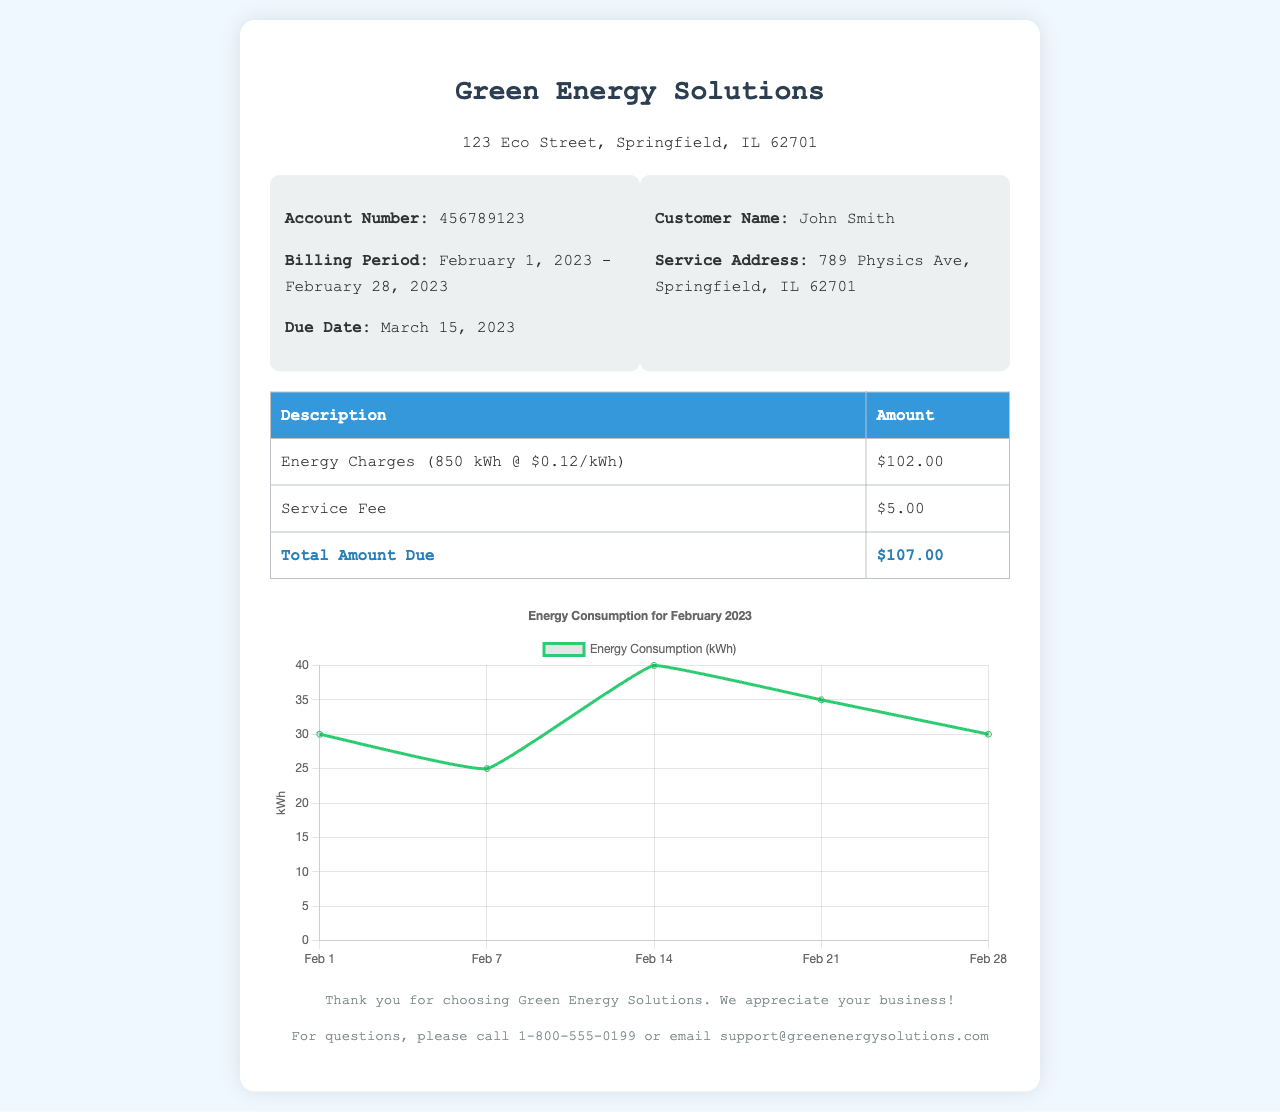what is the account number? The account number is clearly stated in the document.
Answer: 456789123 what is the billing period? The billing period covers the dates mentioned in the document.
Answer: February 1, 2023 - February 28, 2023 who is the customer? The customer's name is provided in the document.
Answer: John Smith what is the total amount due? The total amount due is calculated and presented in the final row of the table.
Answer: $107.00 how many kilowatt-hours were consumed? The energy consumption is mentioned in the energy charges description.
Answer: 850 kWh what was the service fee? The service fee is listed in the table with its specific amount.
Answer: $5.00 what type of chart is displayed? The chart type is specified in the chart creation section of the document.
Answer: line which day had the highest energy consumption? The data points can be analyzed and compared from the chart.
Answer: February 14 how many total charges are listed in the table? The number of charge descriptions can be counted from the table provided.
Answer: 3 